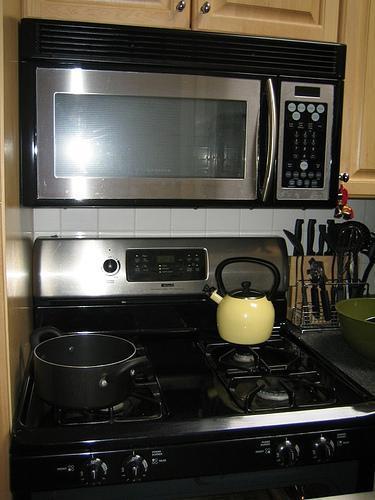How many cars have a surfboard on them?
Give a very brief answer. 0. 